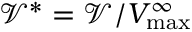<formula> <loc_0><loc_0><loc_500><loc_500>{ \mathcal { V } } ^ { \ast } = { \mathcal { V } } / V _ { \max } ^ { \infty }</formula> 